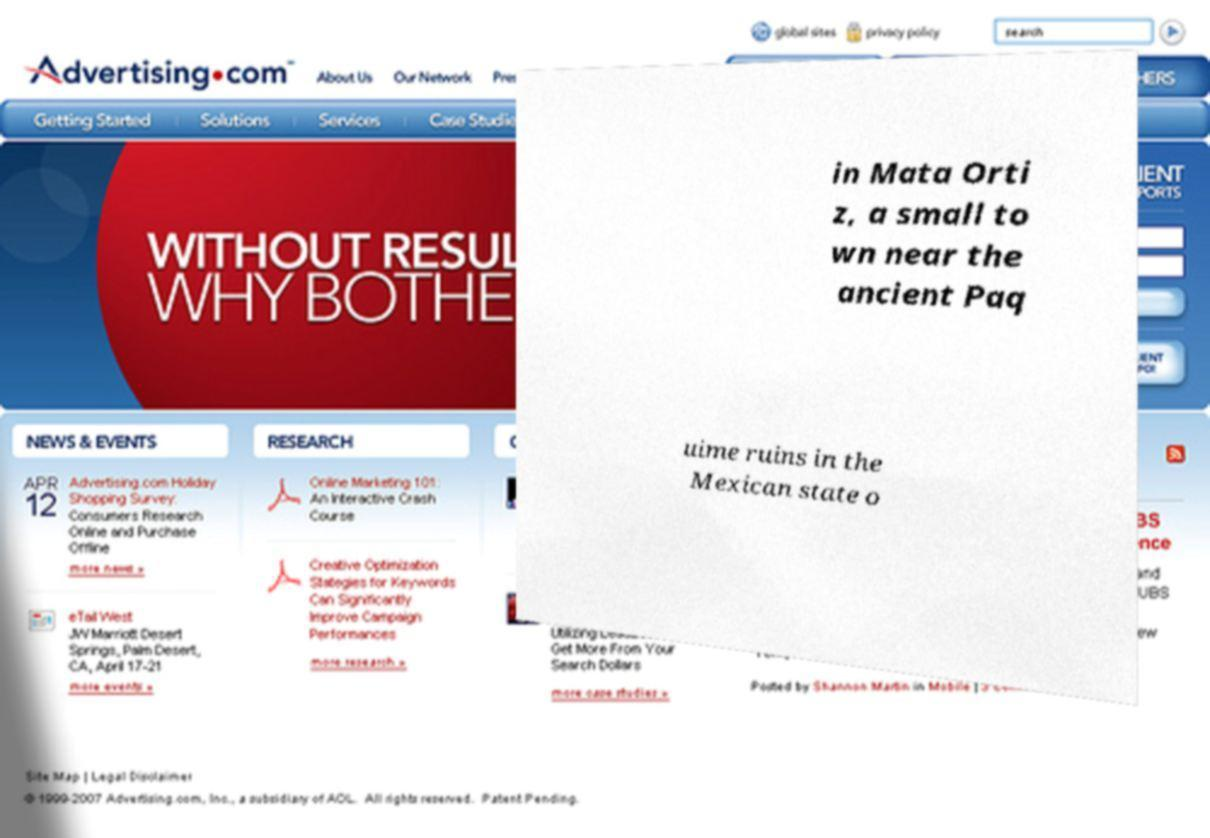Could you extract and type out the text from this image? in Mata Orti z, a small to wn near the ancient Paq uime ruins in the Mexican state o 